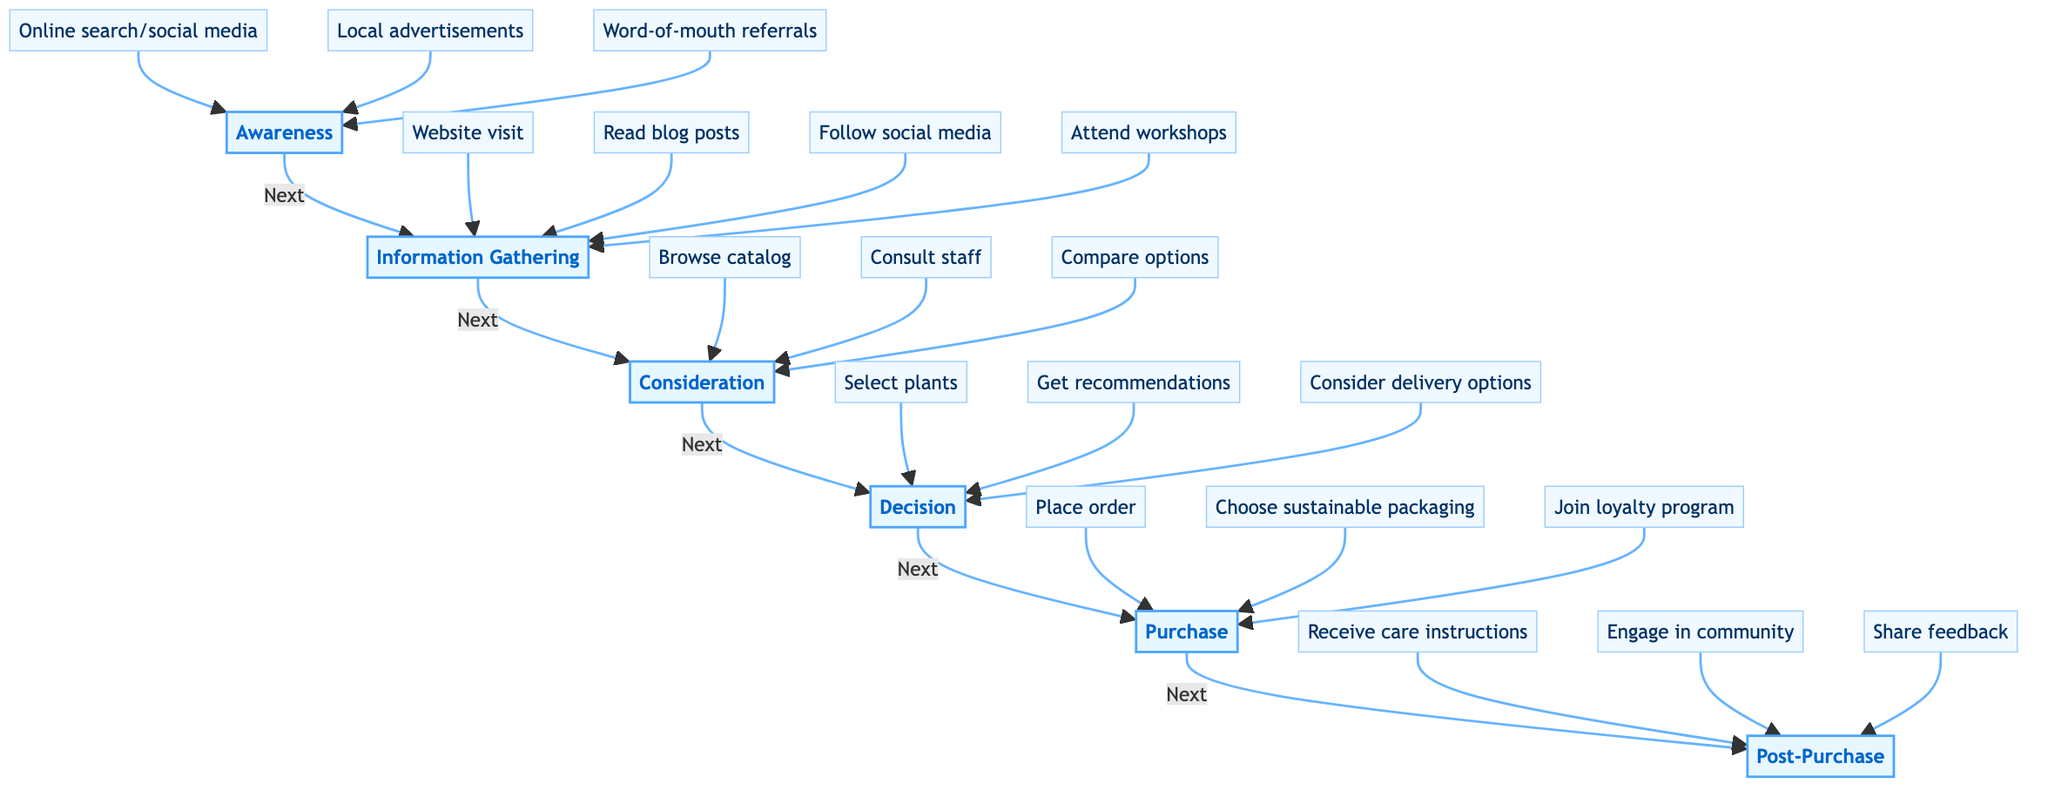What are the stages in the customer journey? The diagram outlines six stages in the customer journey: Awareness, Information Gathering, Consideration, Decision, Purchase, and Post-Purchase.
Answer: Awareness, Information Gathering, Consideration, Decision, Purchase, Post-Purchase How many elements are there in the Awareness stage? In the Awareness stage, there are three elements listed: online search/social media, local advertisements, and word-of-mouth referrals.
Answer: Three What follows the Decision stage? The diagram indicates that the stage following Decision is Purchase.
Answer: Purchase What is one task performed during the Post-Purchase stage? During the Post-Purchase stage, customers receive care instructions and follow-up tips for maintaining purchased plants.
Answer: Receive care instructions Which stage involves attending workshops? The Information Gathering stage involves attending workshops as one of its elements.
Answer: Information Gathering How many total stages are present in the diagram? The diagram contains a total of six stages in the customer journey.
Answer: Six What is emphasized in the advertisements during the Awareness stage? The advertisements during the Awareness stage emphasize the benefits of biodiversity.
Answer: Biodiversity benefits What do customers do in the Consideration stage regarding staff? In the Consideration stage, customers consult with nursery staff about plant care and their impact on biodiversity.
Answer: Consult with nursery staff What is a common activity in the Information Gathering stage related to social media? A common activity in the Information Gathering stage related to social media is following the nursery's social media for tips and customer reviews.
Answer: Follow social media 